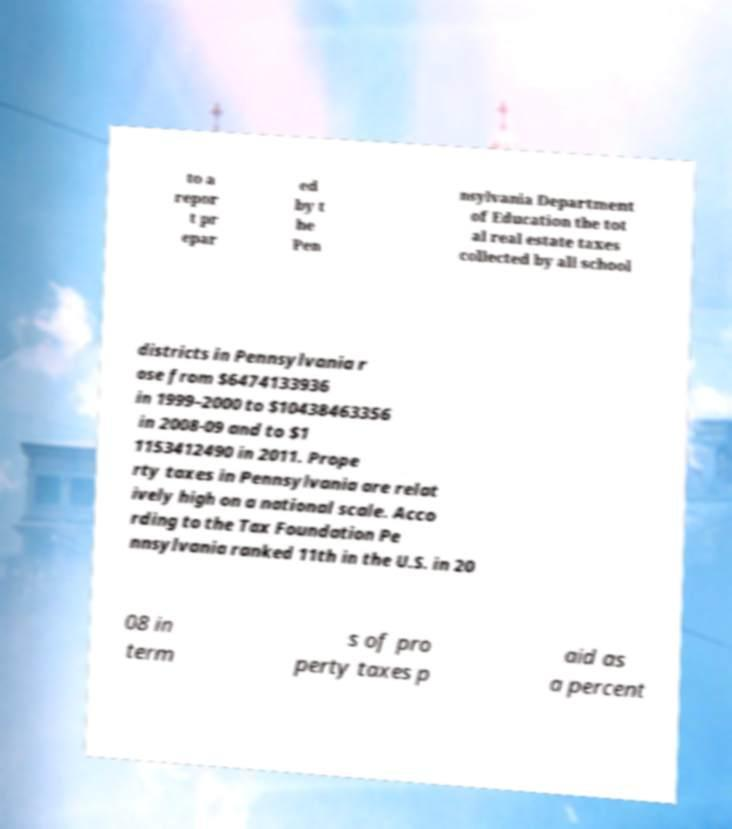Please read and relay the text visible in this image. What does it say? to a repor t pr epar ed by t he Pen nsylvania Department of Education the tot al real estate taxes collected by all school districts in Pennsylvania r ose from $6474133936 in 1999–2000 to $10438463356 in 2008-09 and to $1 1153412490 in 2011. Prope rty taxes in Pennsylvania are relat ively high on a national scale. Acco rding to the Tax Foundation Pe nnsylvania ranked 11th in the U.S. in 20 08 in term s of pro perty taxes p aid as a percent 